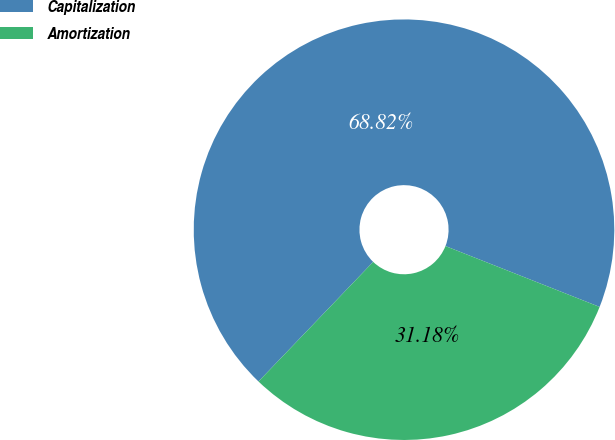Convert chart. <chart><loc_0><loc_0><loc_500><loc_500><pie_chart><fcel>Capitalization<fcel>Amortization<nl><fcel>68.82%<fcel>31.18%<nl></chart> 